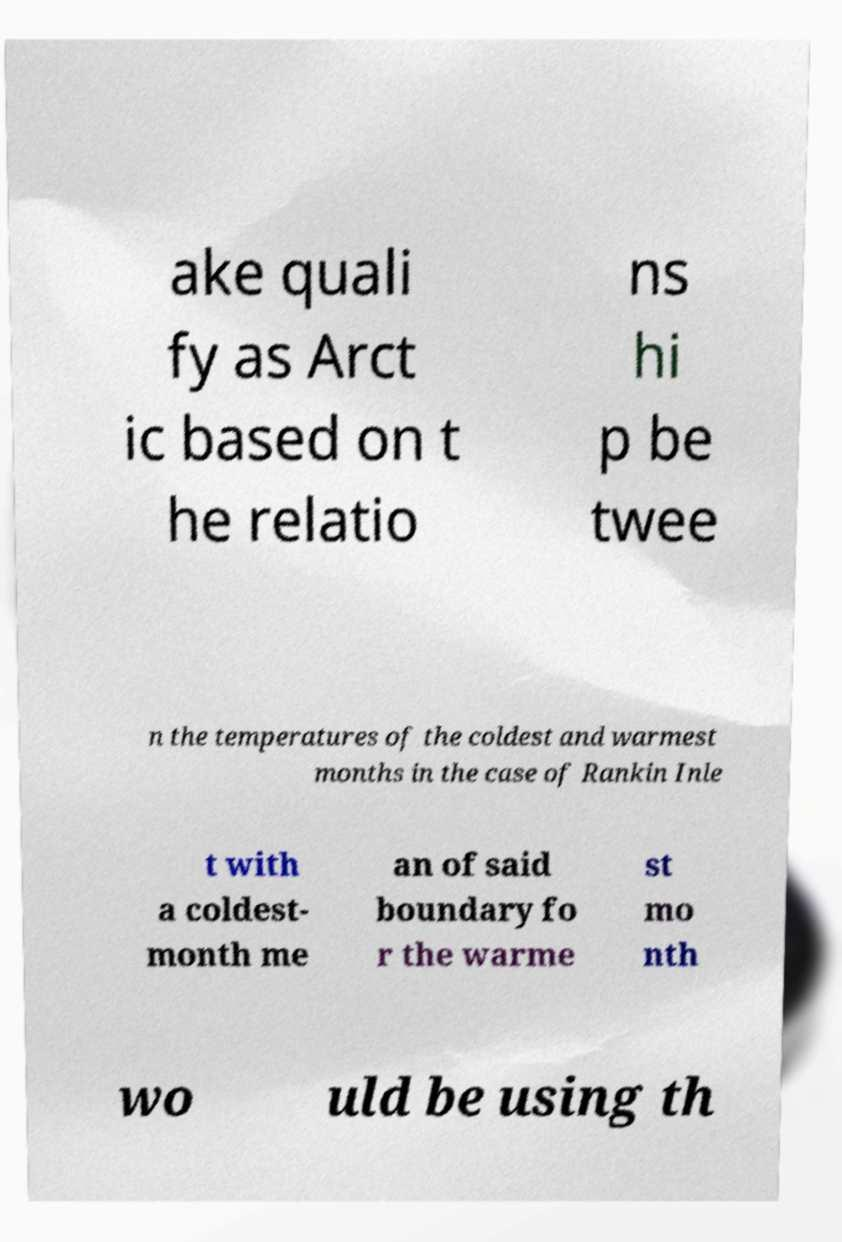Can you read and provide the text displayed in the image?This photo seems to have some interesting text. Can you extract and type it out for me? ake quali fy as Arct ic based on t he relatio ns hi p be twee n the temperatures of the coldest and warmest months in the case of Rankin Inle t with a coldest- month me an of said boundary fo r the warme st mo nth wo uld be using th 